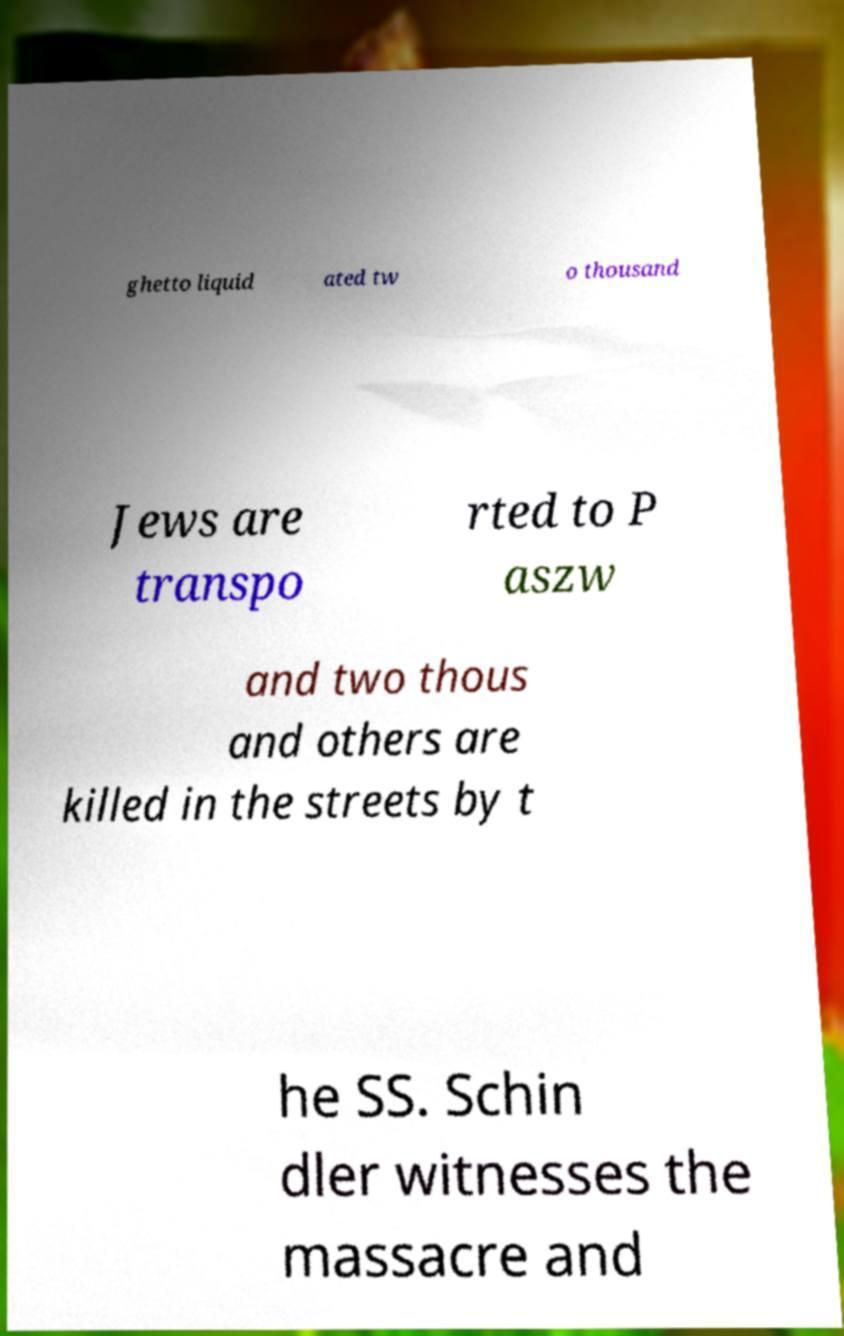Could you extract and type out the text from this image? ghetto liquid ated tw o thousand Jews are transpo rted to P aszw and two thous and others are killed in the streets by t he SS. Schin dler witnesses the massacre and 